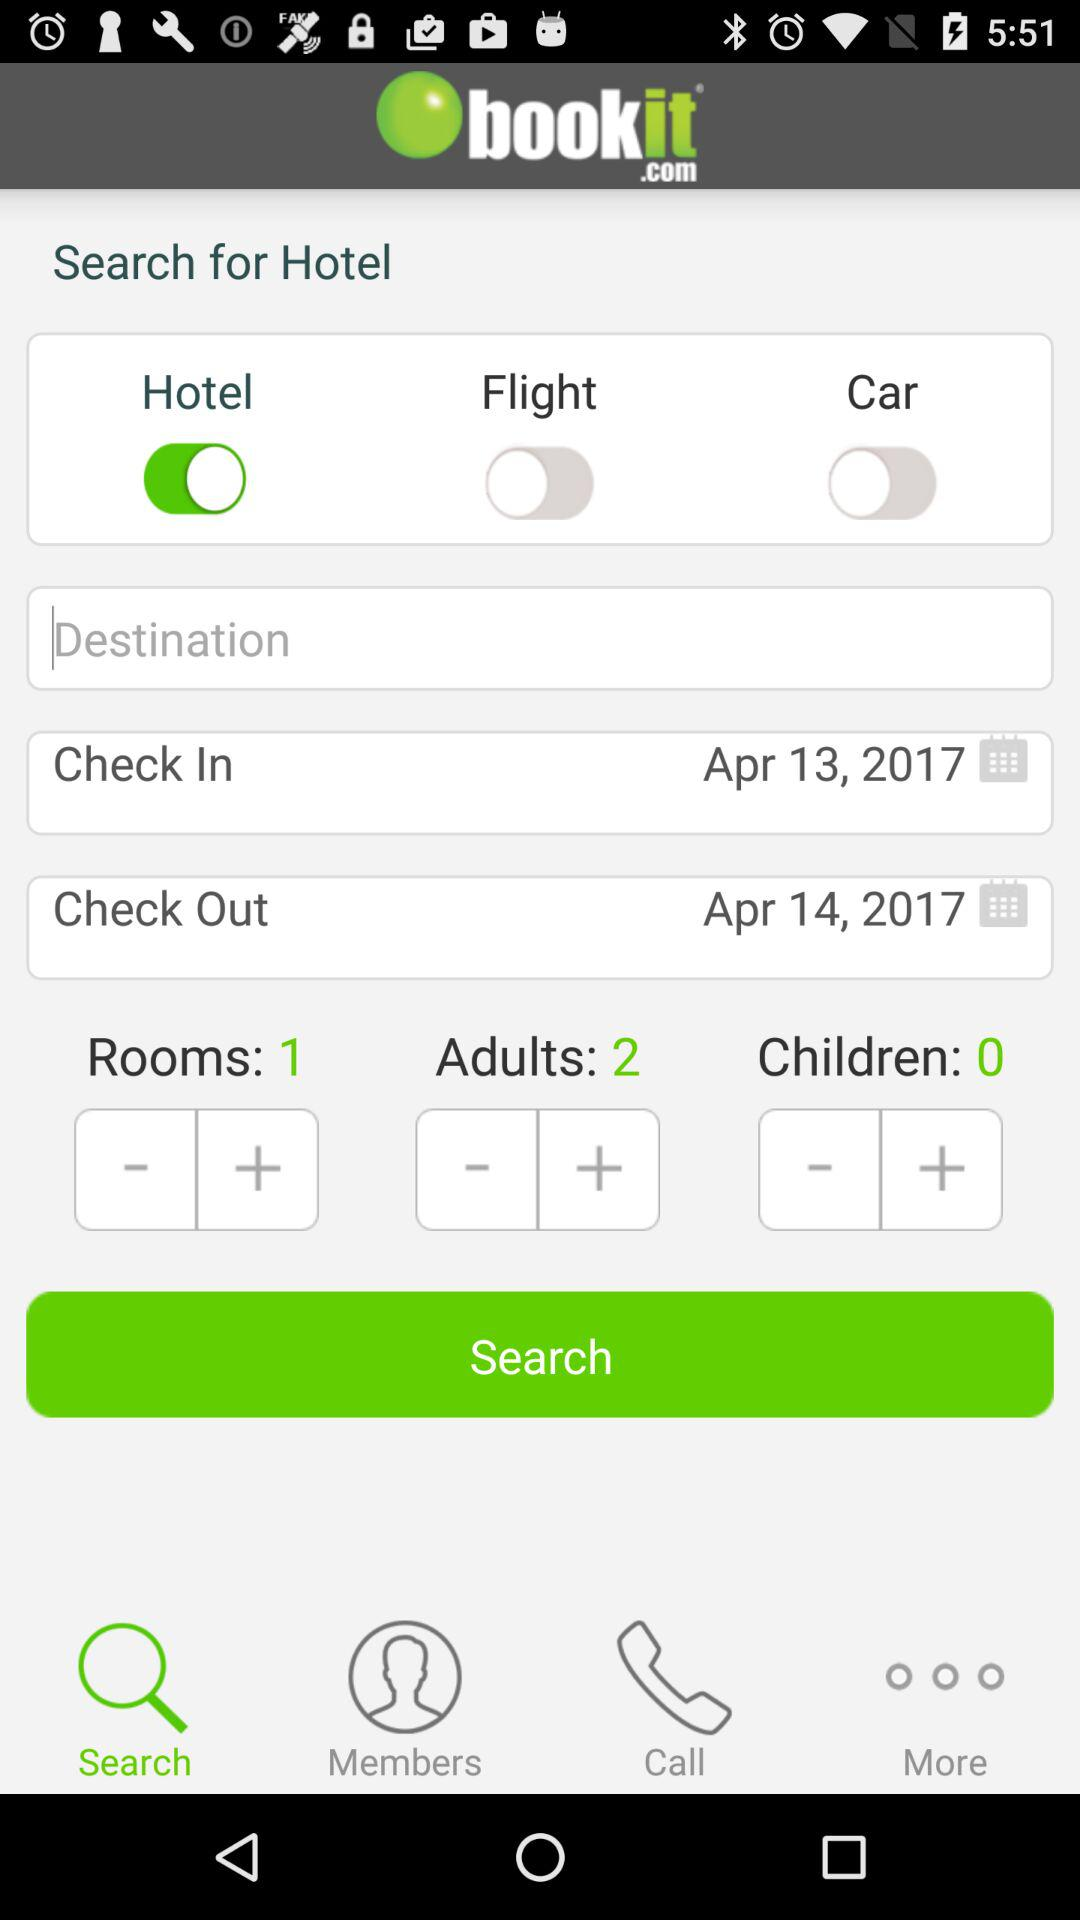What is the application name? The application name is "bookit.com". 